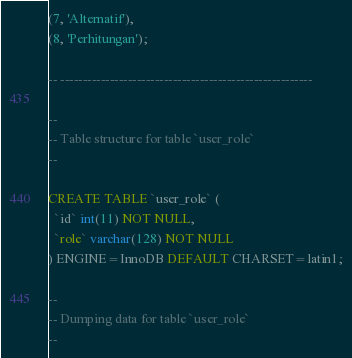Convert code to text. <code><loc_0><loc_0><loc_500><loc_500><_SQL_>(7, 'Alternatif'),
(8, 'Perhitungan');

-- --------------------------------------------------------

--
-- Table structure for table `user_role`
--

CREATE TABLE `user_role` (
  `id` int(11) NOT NULL,
  `role` varchar(128) NOT NULL
) ENGINE=InnoDB DEFAULT CHARSET=latin1;

--
-- Dumping data for table `user_role`
--
</code> 